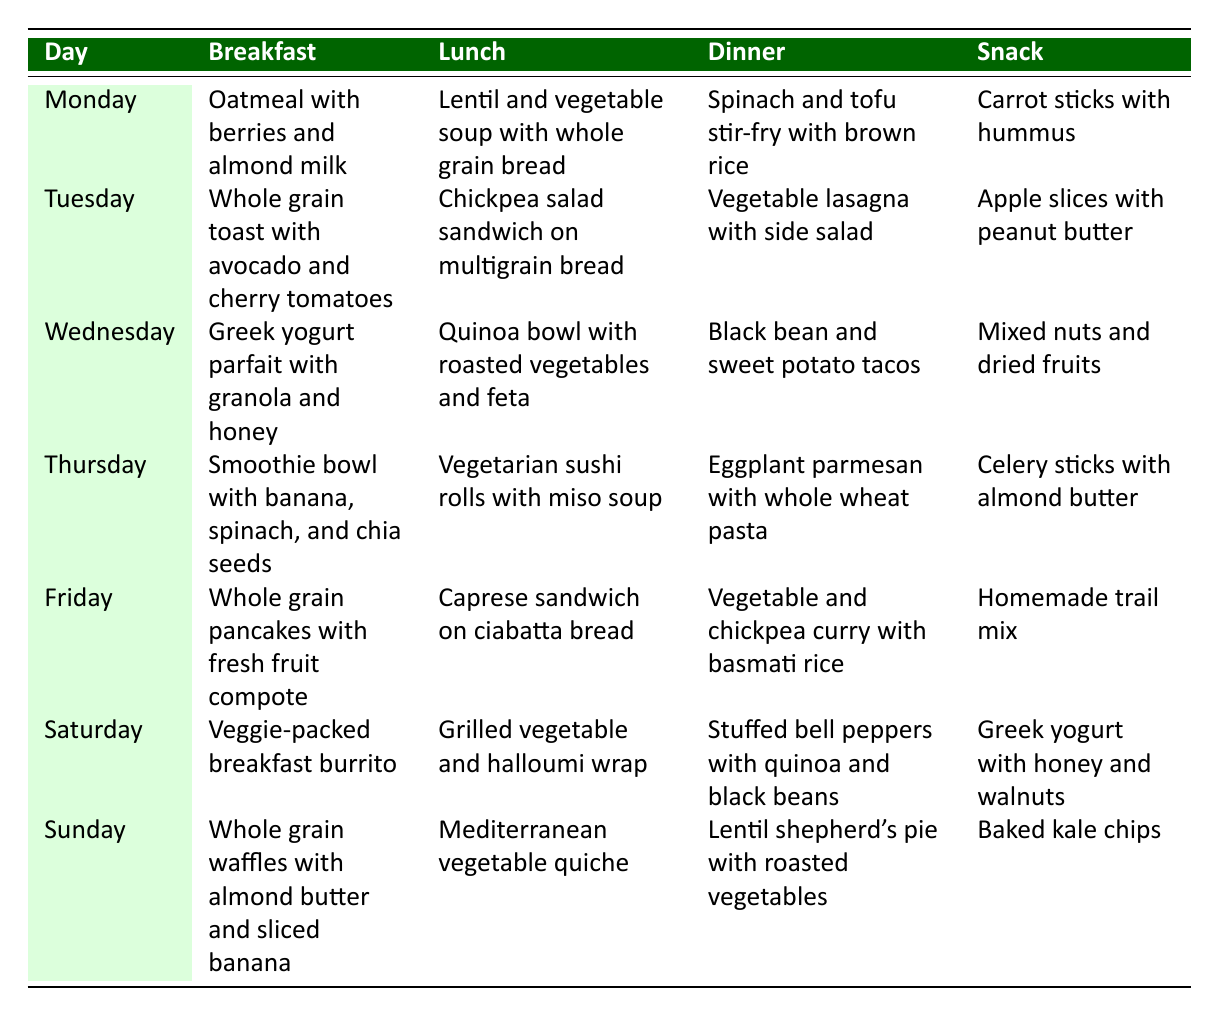What is served for breakfast on Wednesday? The table shows that on Wednesday, the breakfast is "Greek yogurt parfait with granola and honey."
Answer: Greek yogurt parfait with granola and honey Which lunch option contains chickpeas? Looking at the table, "Chickpea salad sandwich on multigrain bread" is included under lunch for Tuesday, making it the lunch option with chickpeas.
Answer: Chickpea salad sandwich on multigrain bread Is vegetable lasagna served for dinner any day of the week? Checking the table, vegetable lasagna is listed under Tuesday's dinner, confirming that it is served on that day.
Answer: No On which day is the snack "Baked kale chips" served? The table indicates that "Baked kale chips" are served on Sunday, as shown in the snack column for Sunday.
Answer: Sunday What is the total number of different types of snacks offered throughout the week? By reviewing the snack options for each day, we find six unique snacks: carrot sticks with hummus, apple slices with peanut butter, mixed nuts and dried fruits, celery sticks with almond butter, homemade trail mix, Greek yogurt with honey and walnuts, and baked kale chips. Thus, the total count is 7.
Answer: 7 Which meal type appears most frequently across the week? The table must be examined for each meal type across breakfast, lunch, dinner, and snack. Each meal type is present seven times (once for each day of the week), indicating they all appear equally.
Answer: All meal types appear equally What is the average number of words in the dinner meals? To calculate the average number of words in the dinner meal options, we count the words in each item (Spinach and tofu stir-fry with brown rice = 6, Vegetable lasagna with side salad = 5, Black bean and sweet potato tacos = 6, Eggplant parmesan with whole wheat pasta = 6, Vegetable and chickpea curry with basmati rice = 7, Stuffed bell peppers with quinoa and black beans = 7, Lentil shepherd's pie with roasted vegetables = 6). The total word count sums to 43 words (6 + 5 + 6 + 6 + 7 + 7 + 6), divided by the number of meals (7), resulting in an average of about 6.14 words per meal.
Answer: 6.14 How many meals throughout the week feature spinach? By analyzing the meals containing spinach, they occur in Monday's dinner (Spinach and tofu stir-fry), Thursday's breakfast (Smoothie bowl with spinach), and Sunday’s dinner (Lentil shepherd’s pie with roasted vegetables). Appearing as part of 3 meals, so the answer is 3.
Answer: 3 